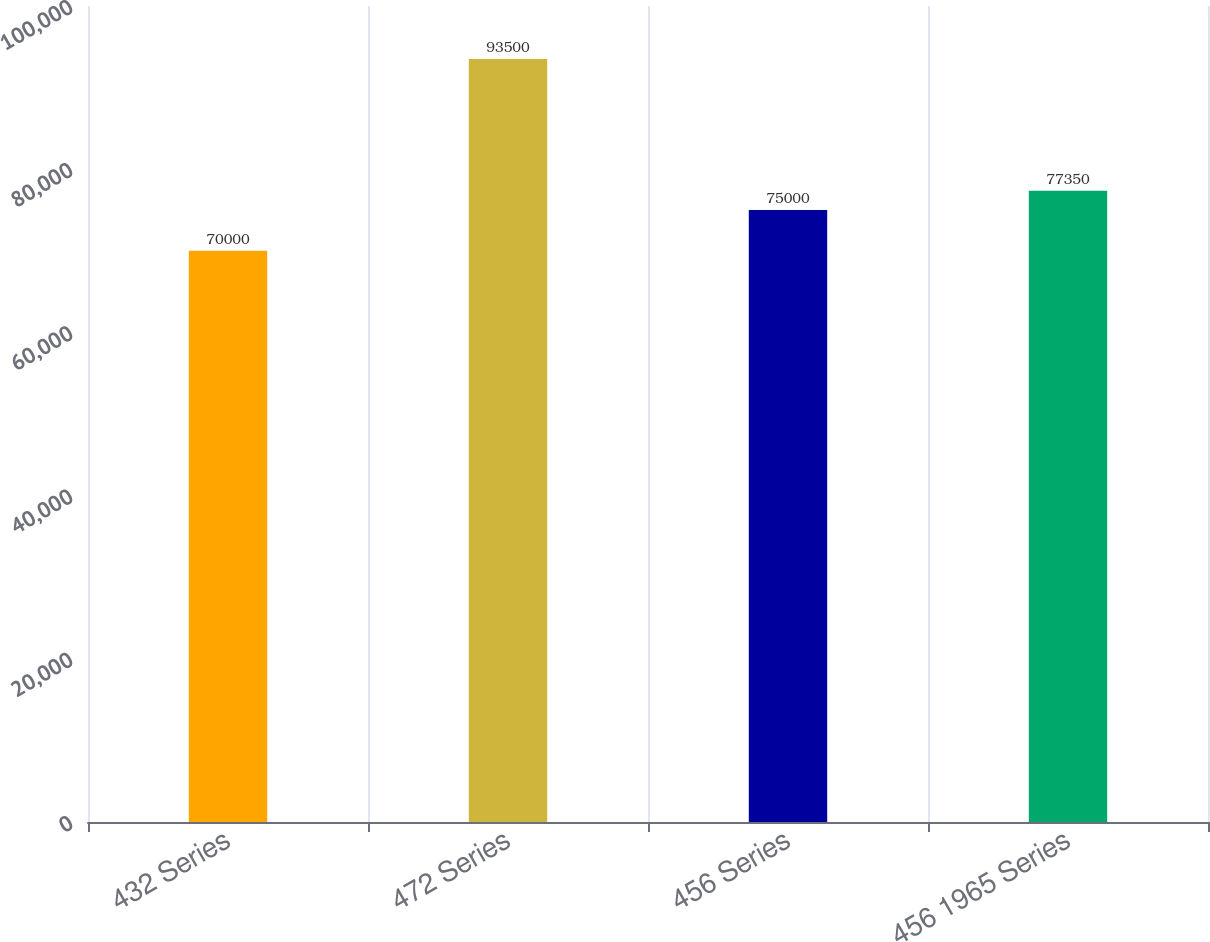Convert chart to OTSL. <chart><loc_0><loc_0><loc_500><loc_500><bar_chart><fcel>432 Series<fcel>472 Series<fcel>456 Series<fcel>456 1965 Series<nl><fcel>70000<fcel>93500<fcel>75000<fcel>77350<nl></chart> 